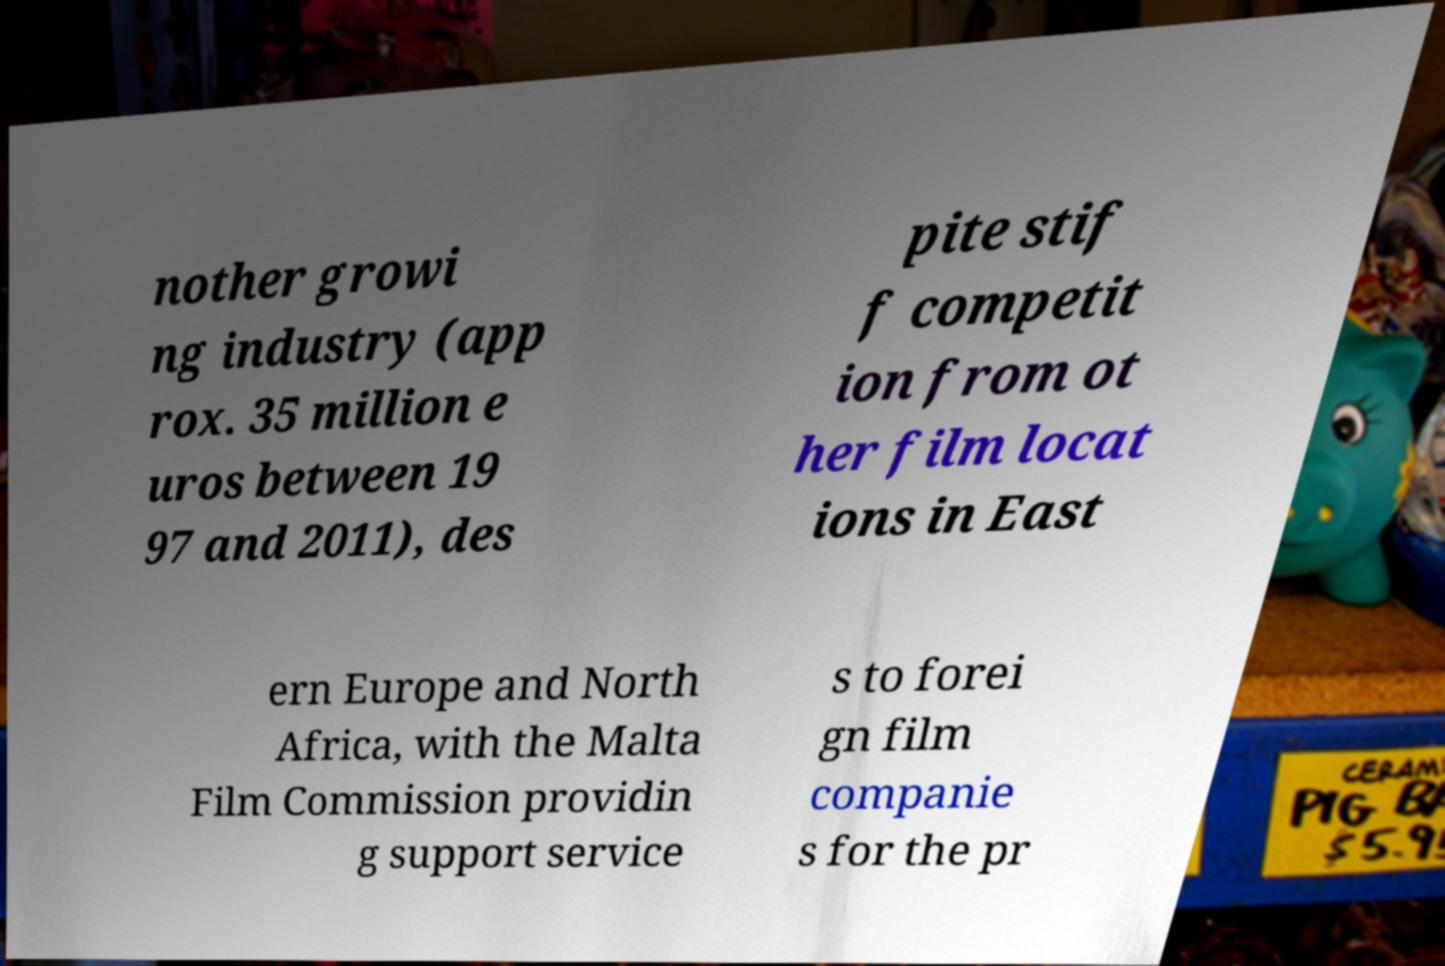There's text embedded in this image that I need extracted. Can you transcribe it verbatim? nother growi ng industry (app rox. 35 million e uros between 19 97 and 2011), des pite stif f competit ion from ot her film locat ions in East ern Europe and North Africa, with the Malta Film Commission providin g support service s to forei gn film companie s for the pr 